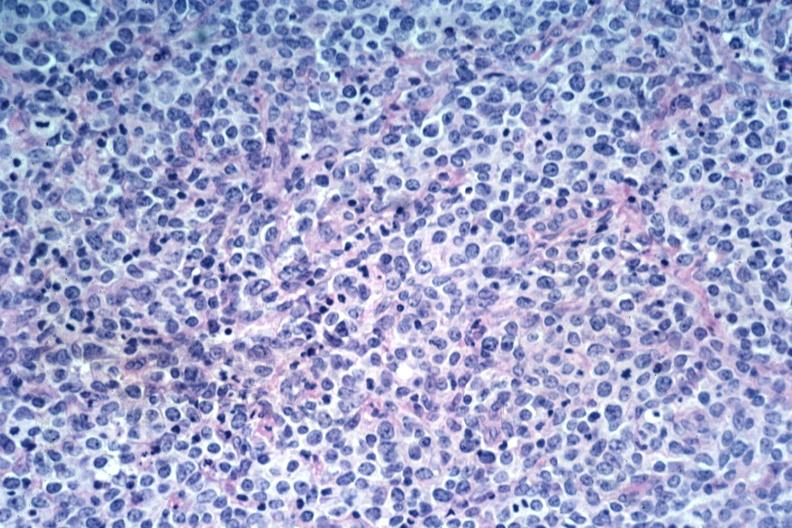what is present?
Answer the question using a single word or phrase. Malignant lymphoma 